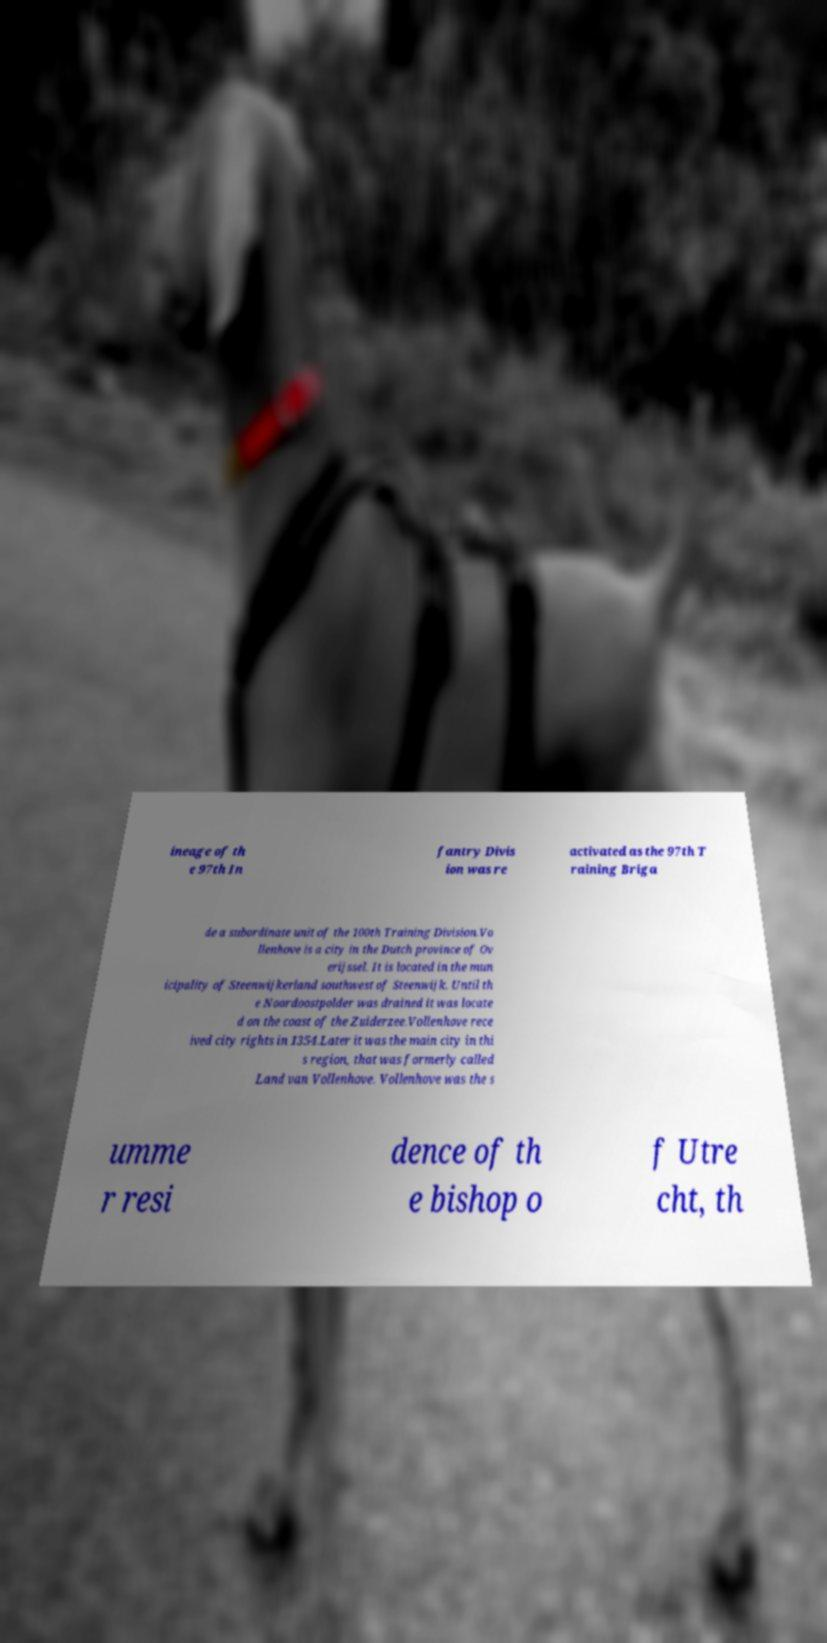There's text embedded in this image that I need extracted. Can you transcribe it verbatim? ineage of th e 97th In fantry Divis ion was re activated as the 97th T raining Briga de a subordinate unit of the 100th Training Division.Vo llenhove is a city in the Dutch province of Ov erijssel. It is located in the mun icipality of Steenwijkerland southwest of Steenwijk. Until th e Noordoostpolder was drained it was locate d on the coast of the Zuiderzee.Vollenhove rece ived city rights in 1354.Later it was the main city in thi s region, that was formerly called Land van Vollenhove. Vollenhove was the s umme r resi dence of th e bishop o f Utre cht, th 